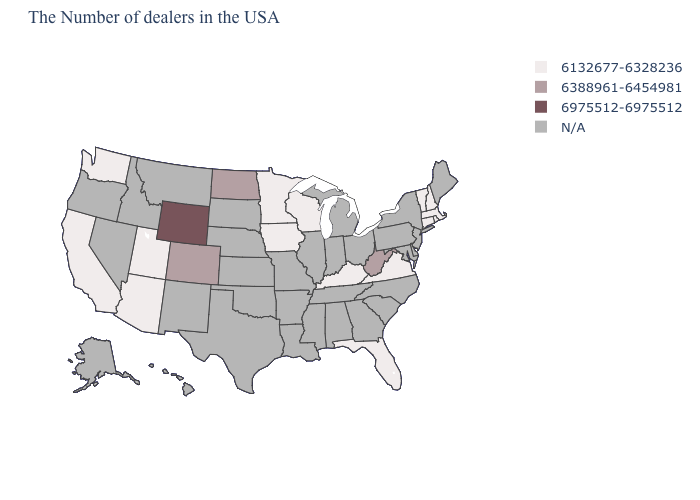What is the value of New York?
Keep it brief. N/A. Which states have the lowest value in the MidWest?
Concise answer only. Wisconsin, Minnesota, Iowa. What is the value of Virginia?
Be succinct. 6132677-6328236. What is the value of Wyoming?
Write a very short answer. 6975512-6975512. What is the lowest value in the West?
Write a very short answer. 6132677-6328236. Name the states that have a value in the range 6975512-6975512?
Keep it brief. Wyoming. What is the highest value in states that border Kansas?
Give a very brief answer. 6388961-6454981. Which states have the lowest value in the South?
Quick response, please. Virginia, Florida, Kentucky. Does Wyoming have the highest value in the USA?
Concise answer only. Yes. What is the highest value in states that border Nevada?
Quick response, please. 6132677-6328236. What is the value of Ohio?
Give a very brief answer. N/A. What is the value of Tennessee?
Short answer required. N/A. 